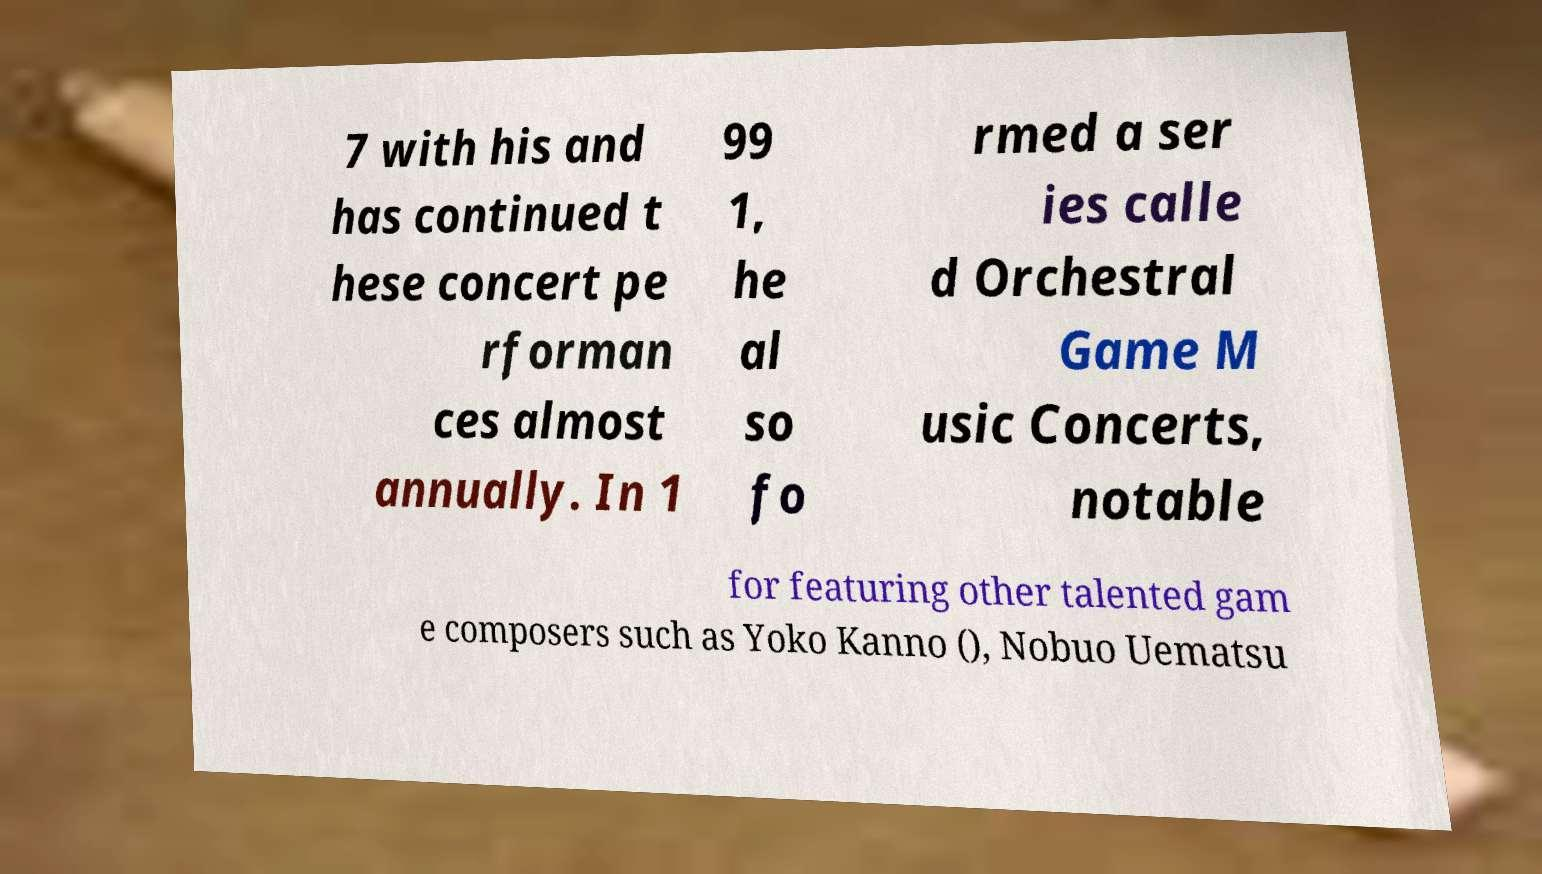I need the written content from this picture converted into text. Can you do that? 7 with his and has continued t hese concert pe rforman ces almost annually. In 1 99 1, he al so fo rmed a ser ies calle d Orchestral Game M usic Concerts, notable for featuring other talented gam e composers such as Yoko Kanno (), Nobuo Uematsu 